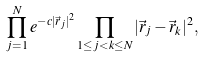<formula> <loc_0><loc_0><loc_500><loc_500>\prod _ { j = 1 } ^ { N } e ^ { - c | \vec { r } _ { j } | ^ { 2 } } \prod _ { 1 \leq j < k \leq N } | \vec { r } _ { j } - \vec { r } _ { k } | ^ { 2 } ,</formula> 